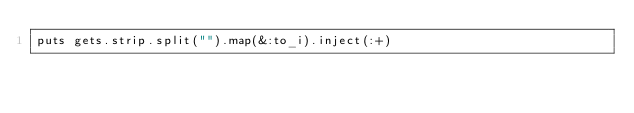Convert code to text. <code><loc_0><loc_0><loc_500><loc_500><_Ruby_>puts gets.strip.split("").map(&:to_i).inject(:+)</code> 